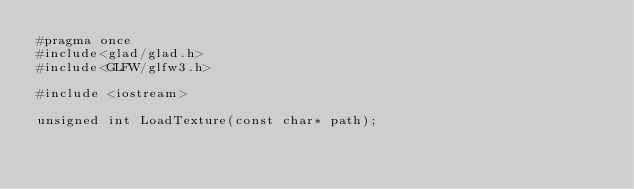Convert code to text. <code><loc_0><loc_0><loc_500><loc_500><_C_>#pragma once
#include<glad/glad.h>
#include<GLFW/glfw3.h>

#include <iostream>

unsigned int LoadTexture(const char* path);
</code> 